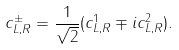<formula> <loc_0><loc_0><loc_500><loc_500>c _ { L , R } ^ { \pm } = \frac { 1 } { \sqrt { 2 } } ( c _ { L , R } ^ { 1 } \mp i c _ { L , R } ^ { 2 } ) .</formula> 